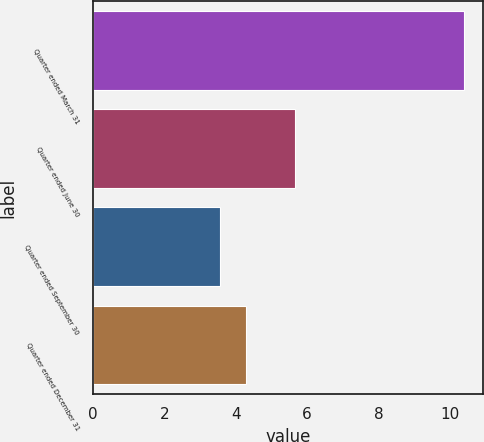Convert chart. <chart><loc_0><loc_0><loc_500><loc_500><bar_chart><fcel>Quarter ended March 31<fcel>Quarter ended June 30<fcel>Quarter ended September 30<fcel>Quarter ended December 31<nl><fcel>10.4<fcel>5.65<fcel>3.55<fcel>4.29<nl></chart> 